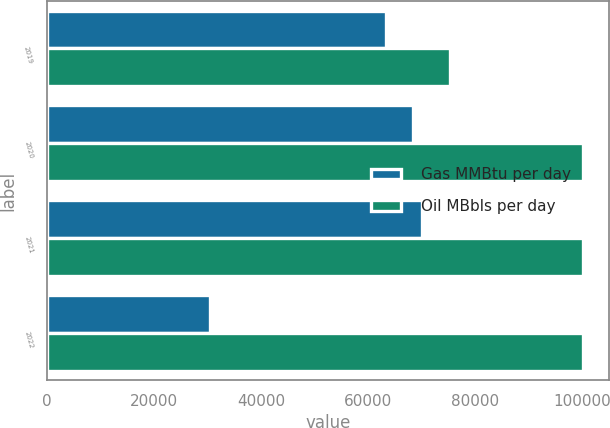Convert chart to OTSL. <chart><loc_0><loc_0><loc_500><loc_500><stacked_bar_chart><ecel><fcel>2019<fcel>2020<fcel>2021<fcel>2022<nl><fcel>Gas MMBtu per day<fcel>63356<fcel>68347<fcel>70000<fcel>30575<nl><fcel>Oil MBbls per day<fcel>75342<fcel>100000<fcel>100000<fcel>100000<nl></chart> 